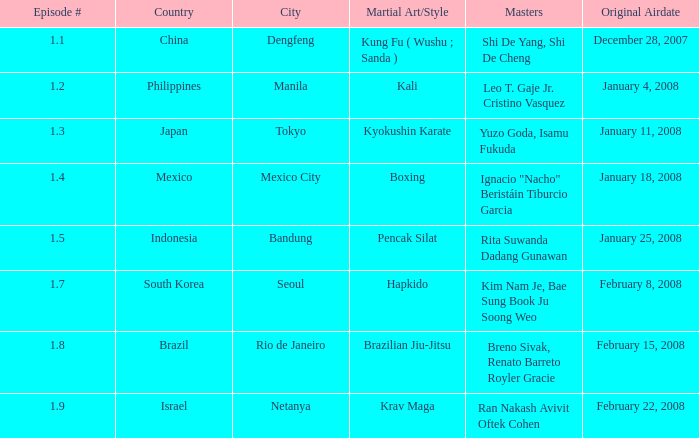How frequently did episode 1.8 get aired? 1.0. Could you parse the entire table as a dict? {'header': ['Episode #', 'Country', 'City', 'Martial Art/Style', 'Masters', 'Original Airdate'], 'rows': [['1.1', 'China', 'Dengfeng', 'Kung Fu ( Wushu ; Sanda )', 'Shi De Yang, Shi De Cheng', 'December 28, 2007'], ['1.2', 'Philippines', 'Manila', 'Kali', 'Leo T. Gaje Jr. Cristino Vasquez', 'January 4, 2008'], ['1.3', 'Japan', 'Tokyo', 'Kyokushin Karate', 'Yuzo Goda, Isamu Fukuda', 'January 11, 2008'], ['1.4', 'Mexico', 'Mexico City', 'Boxing', 'Ignacio "Nacho" Beristáin Tiburcio Garcia', 'January 18, 2008'], ['1.5', 'Indonesia', 'Bandung', 'Pencak Silat', 'Rita Suwanda Dadang Gunawan', 'January 25, 2008'], ['1.7', 'South Korea', 'Seoul', 'Hapkido', 'Kim Nam Je, Bae Sung Book Ju Soong Weo', 'February 8, 2008'], ['1.8', 'Brazil', 'Rio de Janeiro', 'Brazilian Jiu-Jitsu', 'Breno Sivak, Renato Barreto Royler Gracie', 'February 15, 2008'], ['1.9', 'Israel', 'Netanya', 'Krav Maga', 'Ran Nakash Avivit Oftek Cohen', 'February 22, 2008']]} 